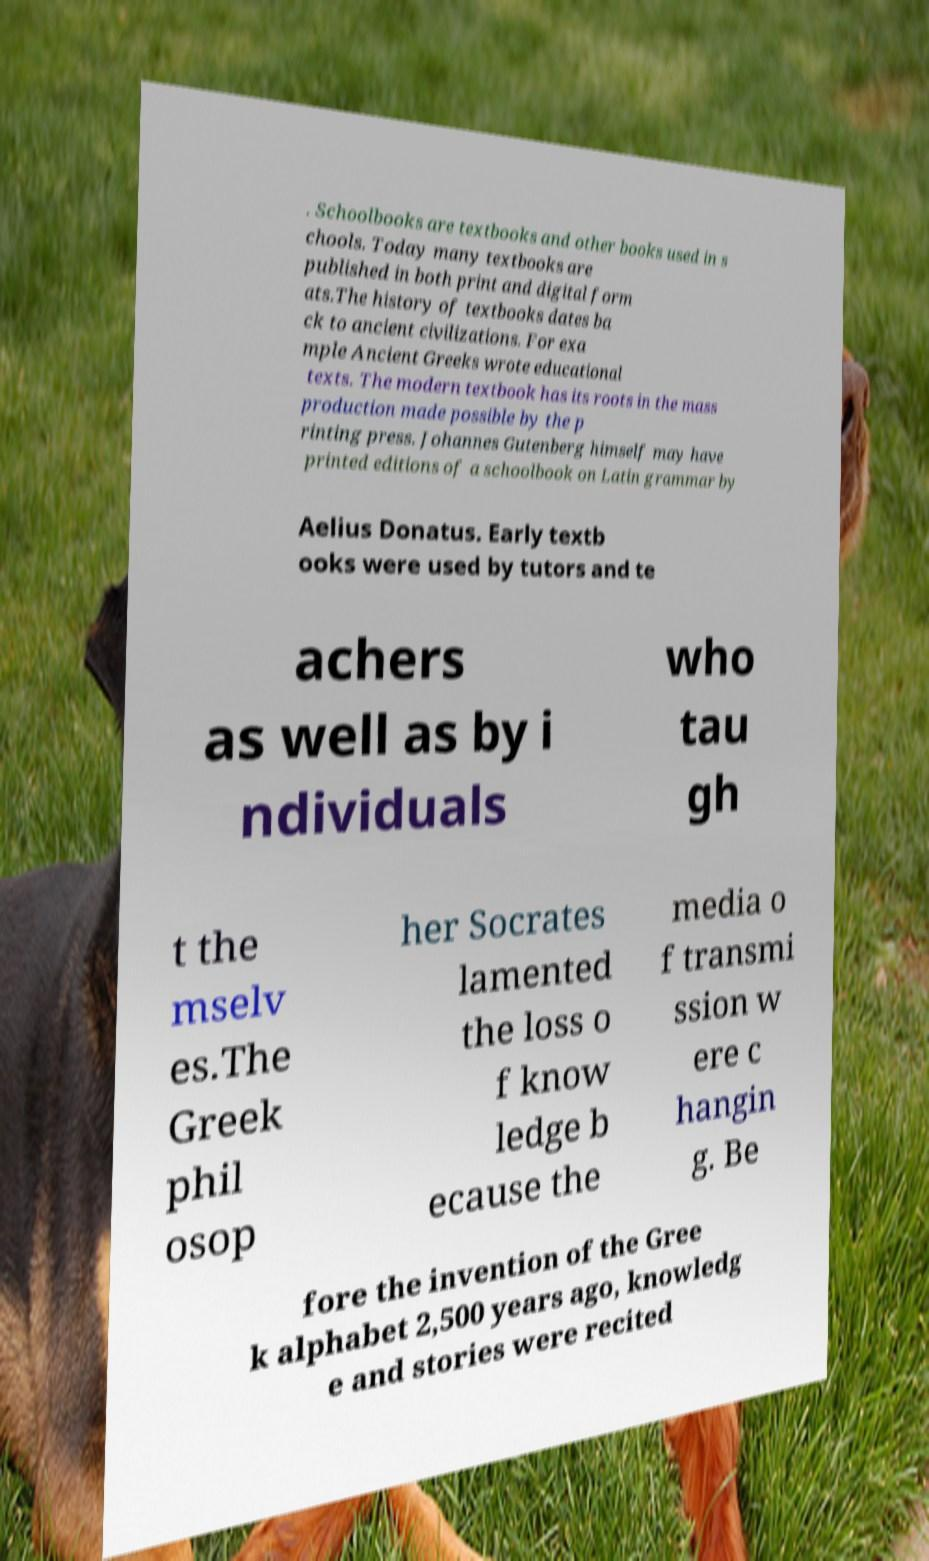Could you assist in decoding the text presented in this image and type it out clearly? . Schoolbooks are textbooks and other books used in s chools. Today many textbooks are published in both print and digital form ats.The history of textbooks dates ba ck to ancient civilizations. For exa mple Ancient Greeks wrote educational texts. The modern textbook has its roots in the mass production made possible by the p rinting press. Johannes Gutenberg himself may have printed editions of a schoolbook on Latin grammar by Aelius Donatus. Early textb ooks were used by tutors and te achers as well as by i ndividuals who tau gh t the mselv es.The Greek phil osop her Socrates lamented the loss o f know ledge b ecause the media o f transmi ssion w ere c hangin g. Be fore the invention of the Gree k alphabet 2,500 years ago, knowledg e and stories were recited 